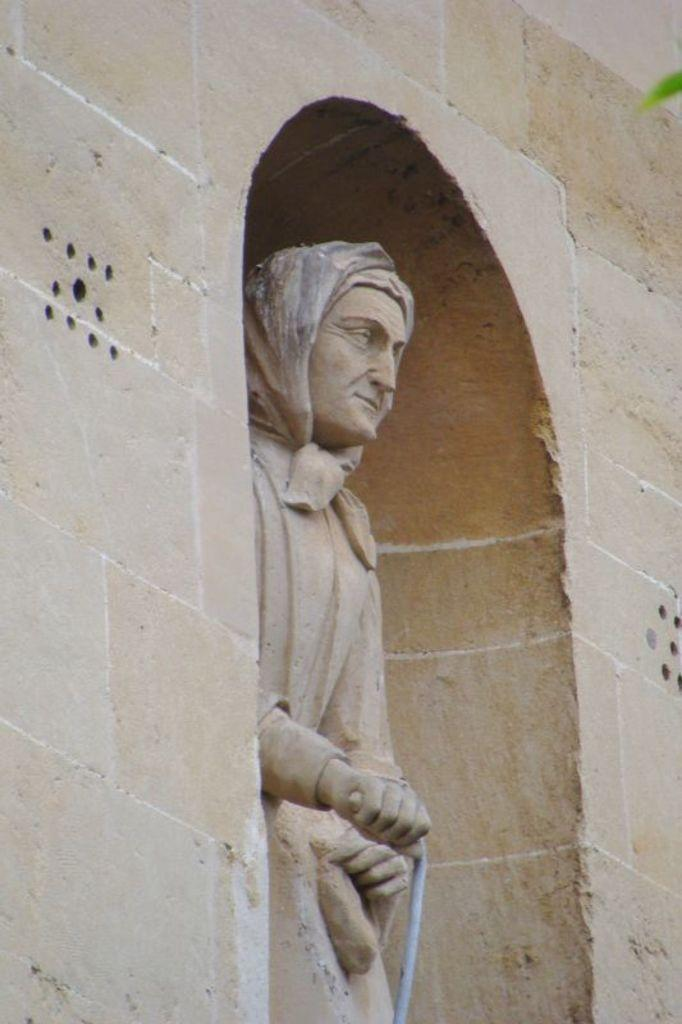What is the main structure visible in the image? There is a wall in the image. What can be seen in the middle of the image? There is a statue in the middle of the image. What type of vegetation is on the right side of the image? There is a leaf on the right side of the image. What type of news can be heard coming from the government building in the image? There is no government building or news present in the image; it features a wall and a statue. What type of truck is parked near the statue in the image? There is no truck present in the image; it only features a wall, a statue, and a leaf. 